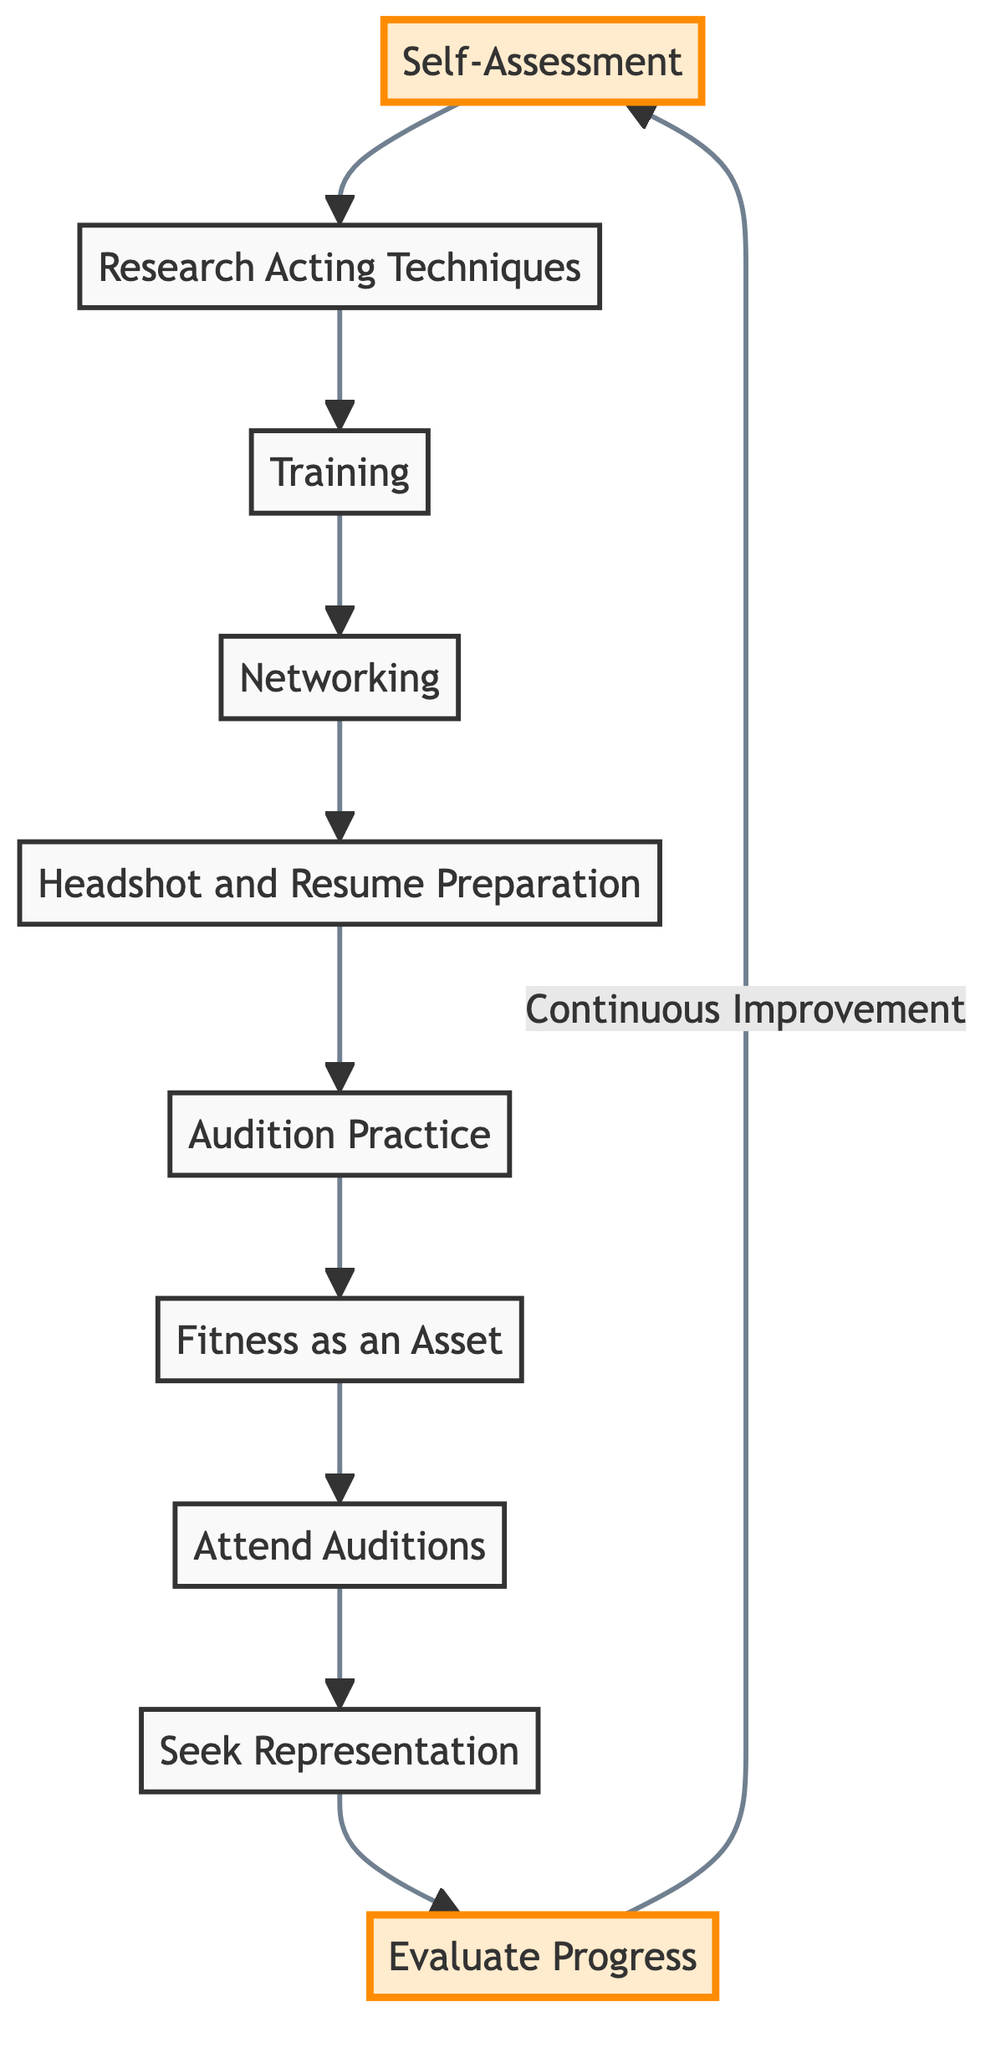What is the first step in the transition process? The flow chart begins with the node labeled "Self-Assessment," indicating it is the first step in the process.
Answer: Self-Assessment How many total steps are represented in the diagram? By counting the nodes in the diagram, there are a total of ten steps involved in transitioning from fitness competitions to acting auditions.
Answer: 10 What follows "Headshot and Resume Preparation"? In the flow direction, the step directly following "Headshot and Resume Preparation" is "Audition Practice."
Answer: Audition Practice What is the last step in this process? In the flow chart, the last node is labeled "Evaluate Progress," indicating it is the final step before returning to "Self-Assessment" for continuous improvement.
Answer: Evaluate Progress How many training methods are mentioned before Networking? There is one node labeled "Training" that comes before "Networking," so the answer refers to training methods that should be explored as part of the Training step.
Answer: 1 What relationship exists between "Attend Auditions" and "Seek Representation"? The flow establishes a sequential relationship where "Attend Auditions" leads directly to "Seek Representation," indicating that attending auditions is a precursor to seeking representation.
Answer: Sequential Which step emphasizes the importance of fitness in acting roles? The node labeled "Fitness as an Asset" emphasizes the importance of leveraging fitness background for physically demanding roles in acting.
Answer: Fitness as an Asset What does the diagram recommend doing after "Audition Practice"? After "Audition Practice," the diagram indicates that the next step is to "Fitness as an Asset," suggesting that this step follows practice preparation.
Answer: Fitness as an Asset What is the purpose of the "Networking" step? The "Networking" step aims to connect with acting coaches, agents, and industry professionals, fostering relationships that can assist in the acting career.
Answer: Connect with professionals How does the process cycle back to the beginning? The cycle is indicated by the arrow pointing from "Evaluate Progress" back to "Self-Assessment," committing to continuous improvement through regular evaluations.
Answer: Continuous Improvement 